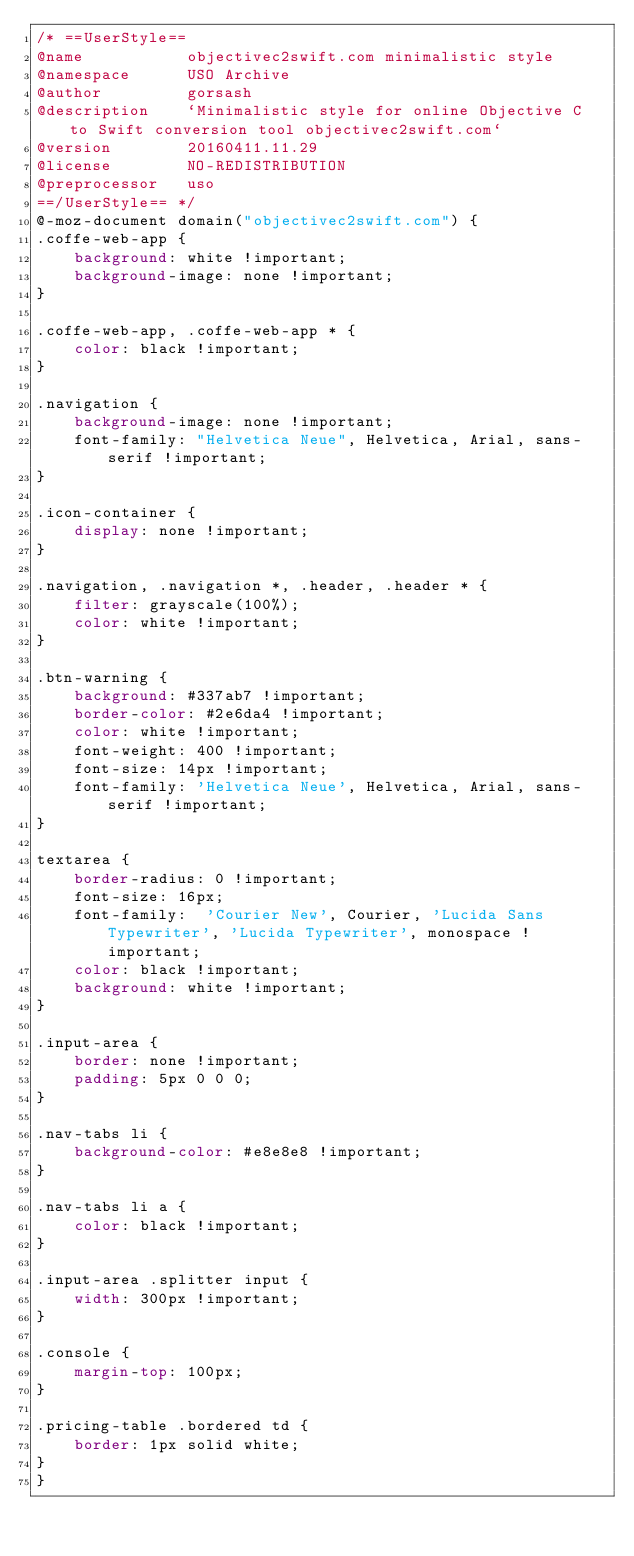Convert code to text. <code><loc_0><loc_0><loc_500><loc_500><_CSS_>/* ==UserStyle==
@name           objectivec2swift.com minimalistic style
@namespace      USO Archive
@author         gorsash
@description    `Minimalistic style for online Objective C to Swift conversion tool objectivec2swift.com`
@version        20160411.11.29
@license        NO-REDISTRIBUTION
@preprocessor   uso
==/UserStyle== */
@-moz-document domain("objectivec2swift.com") {
.coffe-web-app {
    background: white !important;
	background-image: none !important;
}

.coffe-web-app, .coffe-web-app * {
    color: black !important;
}

.navigation {
	background-image: none !important;
    font-family: "Helvetica Neue", Helvetica, Arial, sans-serif !important;
}

.icon-container {
	display: none !important;
}

.navigation, .navigation *, .header, .header * {
	filter: grayscale(100%);
	color: white !important;
}

.btn-warning {
	background: #337ab7 !important;
    border-color: #2e6da4 !important;
    color: white !important;
    font-weight: 400 !important;
    font-size: 14px !important;
    font-family: 'Helvetica Neue', Helvetica, Arial, sans-serif !important;
}

textarea {
	border-radius: 0 !important;
    font-size: 16px;
    font-family:  'Courier New', Courier, 'Lucida Sans Typewriter', 'Lucida Typewriter', monospace !important;
    color: black !important;
    background: white !important;
}

.input-area {
	border: none !important;
    padding: 5px 0 0 0;
}

.nav-tabs li {
	background-color: #e8e8e8 !important;
}

.nav-tabs li a {
    color: black !important;
}

.input-area .splitter input {
    width: 300px !important;   
}

.console {
    margin-top: 100px;
}

.pricing-table .bordered td {
    border: 1px solid white;
}
}</code> 